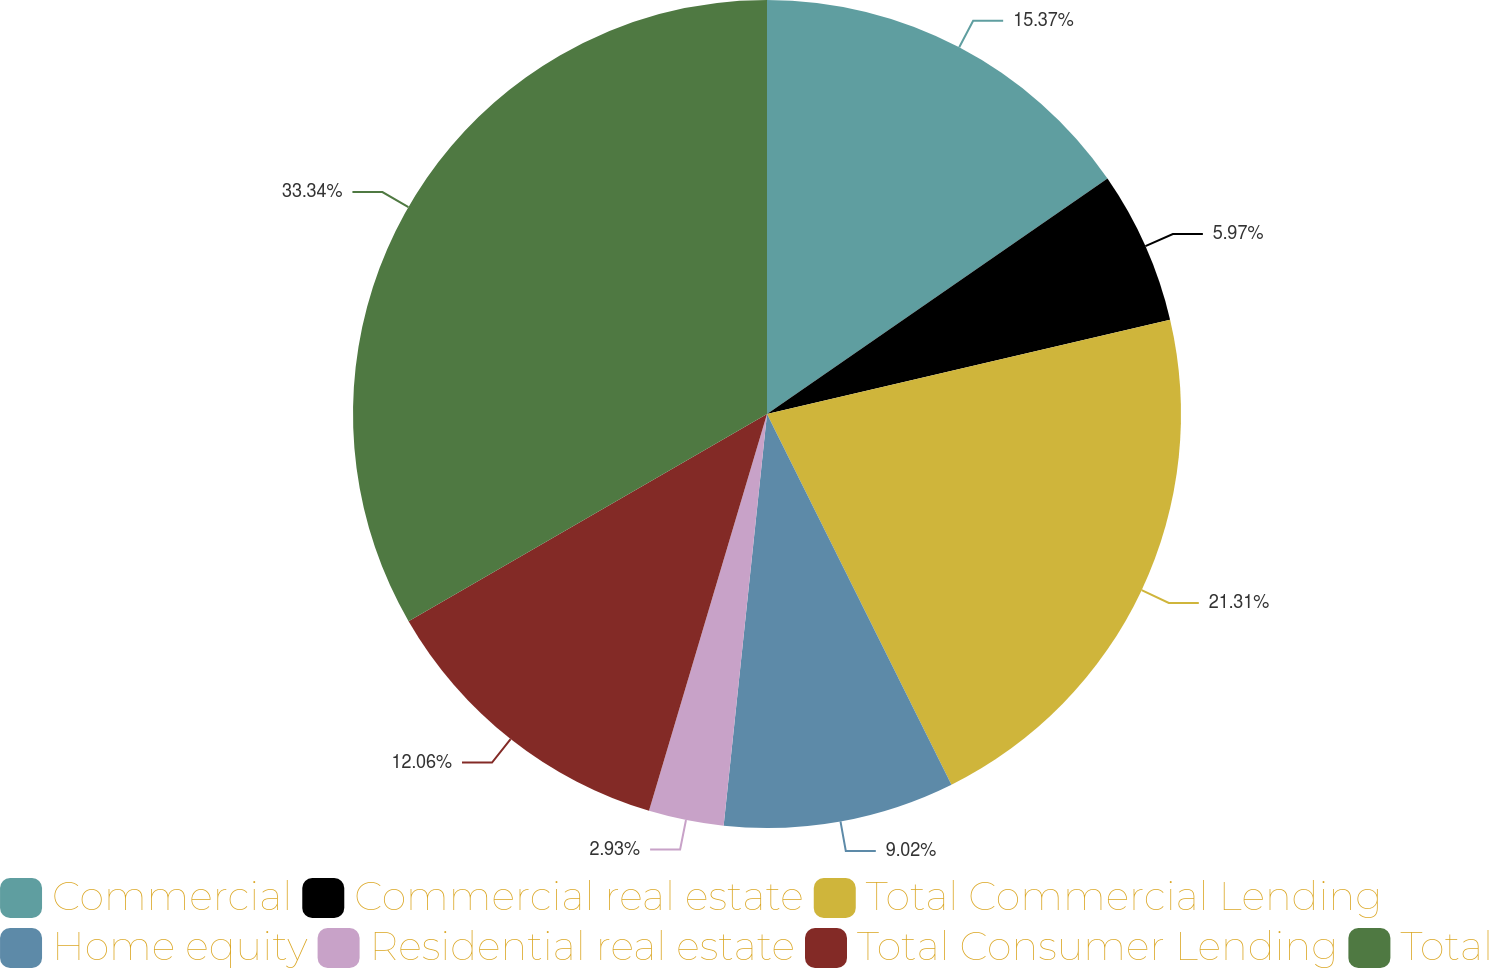Convert chart. <chart><loc_0><loc_0><loc_500><loc_500><pie_chart><fcel>Commercial<fcel>Commercial real estate<fcel>Total Commercial Lending<fcel>Home equity<fcel>Residential real estate<fcel>Total Consumer Lending<fcel>Total<nl><fcel>15.37%<fcel>5.97%<fcel>21.31%<fcel>9.02%<fcel>2.93%<fcel>12.06%<fcel>33.34%<nl></chart> 